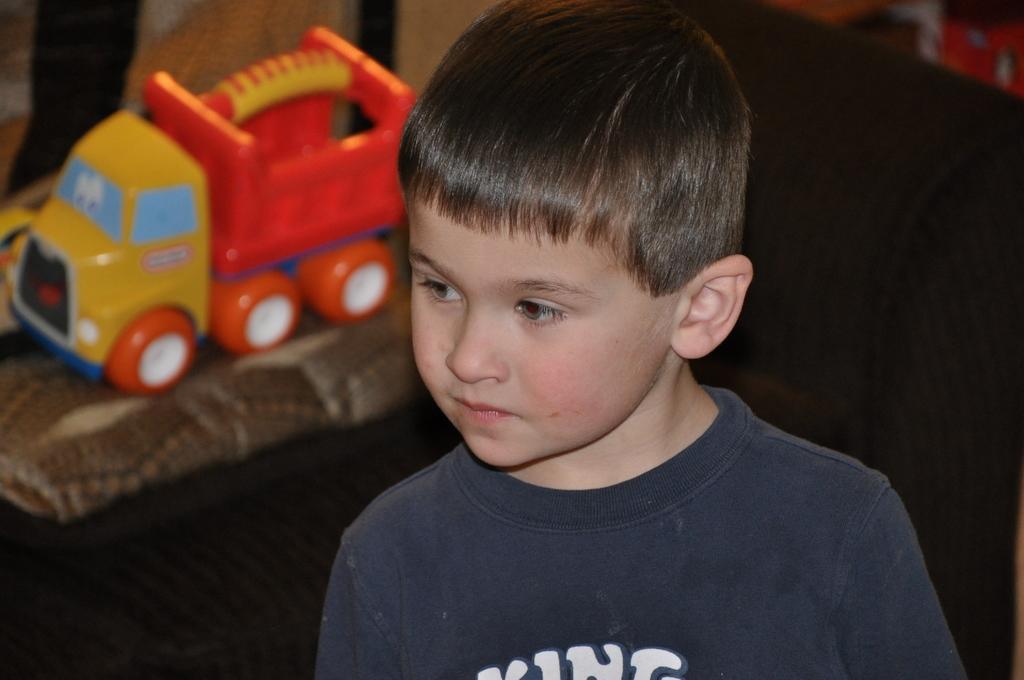Please provide a concise description of this image. In this image in front there is a boy. Behind him there are toys on the cloth. At the bottom of the image there is a floor. On the right side of the image there are toys. 